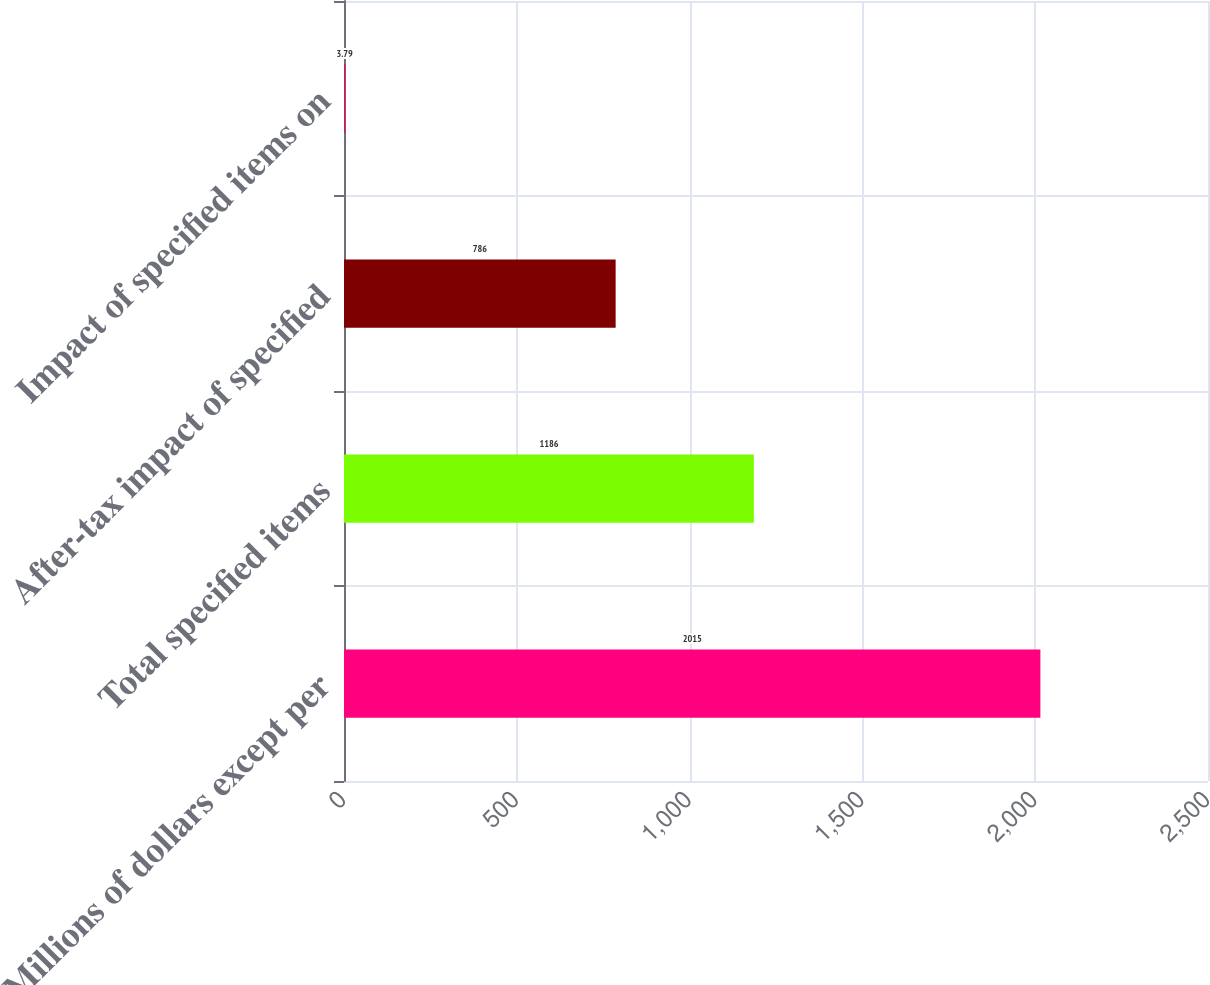Convert chart to OTSL. <chart><loc_0><loc_0><loc_500><loc_500><bar_chart><fcel>Millions of dollars except per<fcel>Total specified items<fcel>After-tax impact of specified<fcel>Impact of specified items on<nl><fcel>2015<fcel>1186<fcel>786<fcel>3.79<nl></chart> 